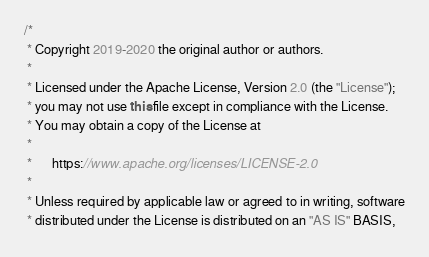<code> <loc_0><loc_0><loc_500><loc_500><_Java_>/*
 * Copyright 2019-2020 the original author or authors.
 *
 * Licensed under the Apache License, Version 2.0 (the "License");
 * you may not use this file except in compliance with the License.
 * You may obtain a copy of the License at
 *
 *      https://www.apache.org/licenses/LICENSE-2.0
 *
 * Unless required by applicable law or agreed to in writing, software
 * distributed under the License is distributed on an "AS IS" BASIS,</code> 